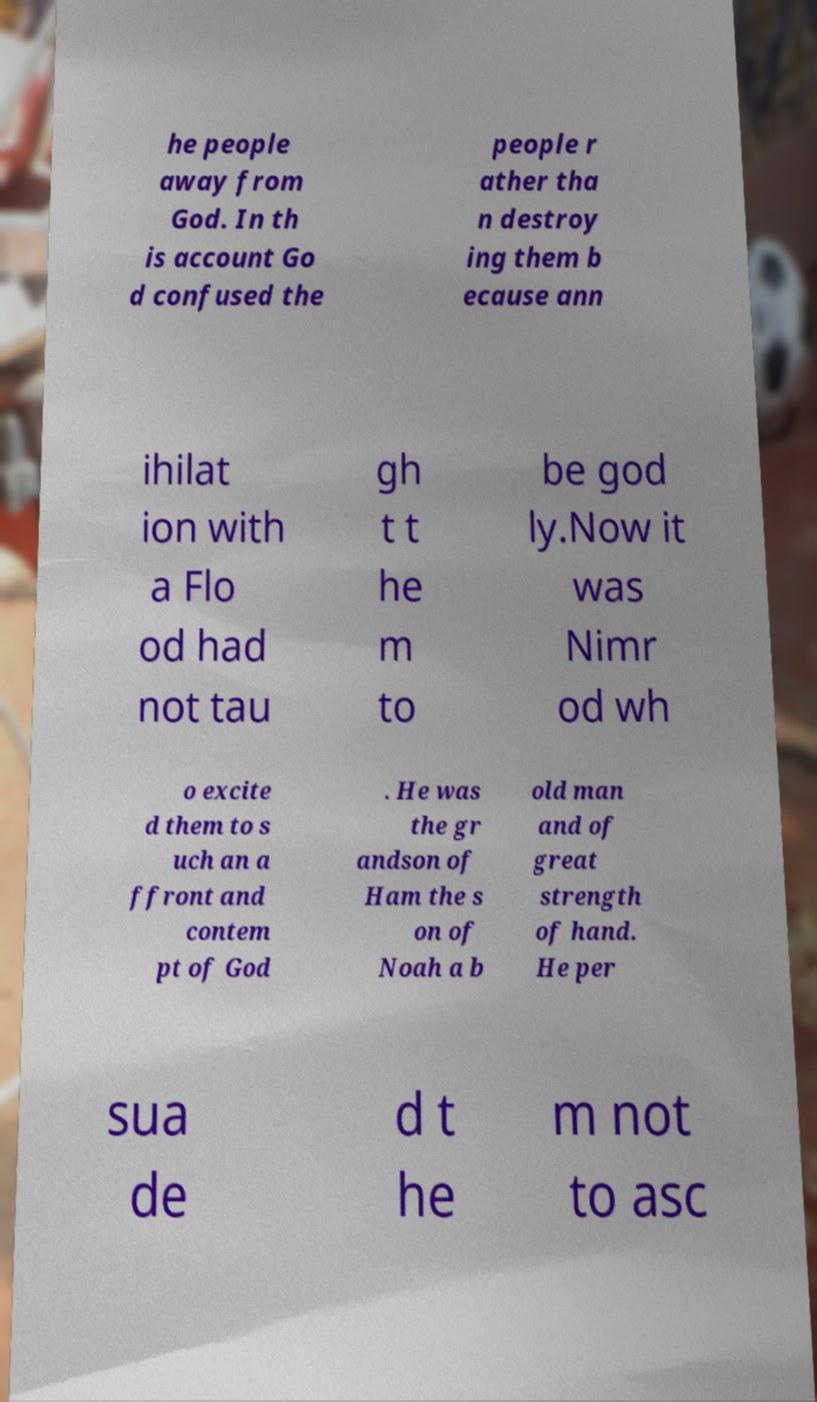I need the written content from this picture converted into text. Can you do that? he people away from God. In th is account Go d confused the people r ather tha n destroy ing them b ecause ann ihilat ion with a Flo od had not tau gh t t he m to be god ly.Now it was Nimr od wh o excite d them to s uch an a ffront and contem pt of God . He was the gr andson of Ham the s on of Noah a b old man and of great strength of hand. He per sua de d t he m not to asc 